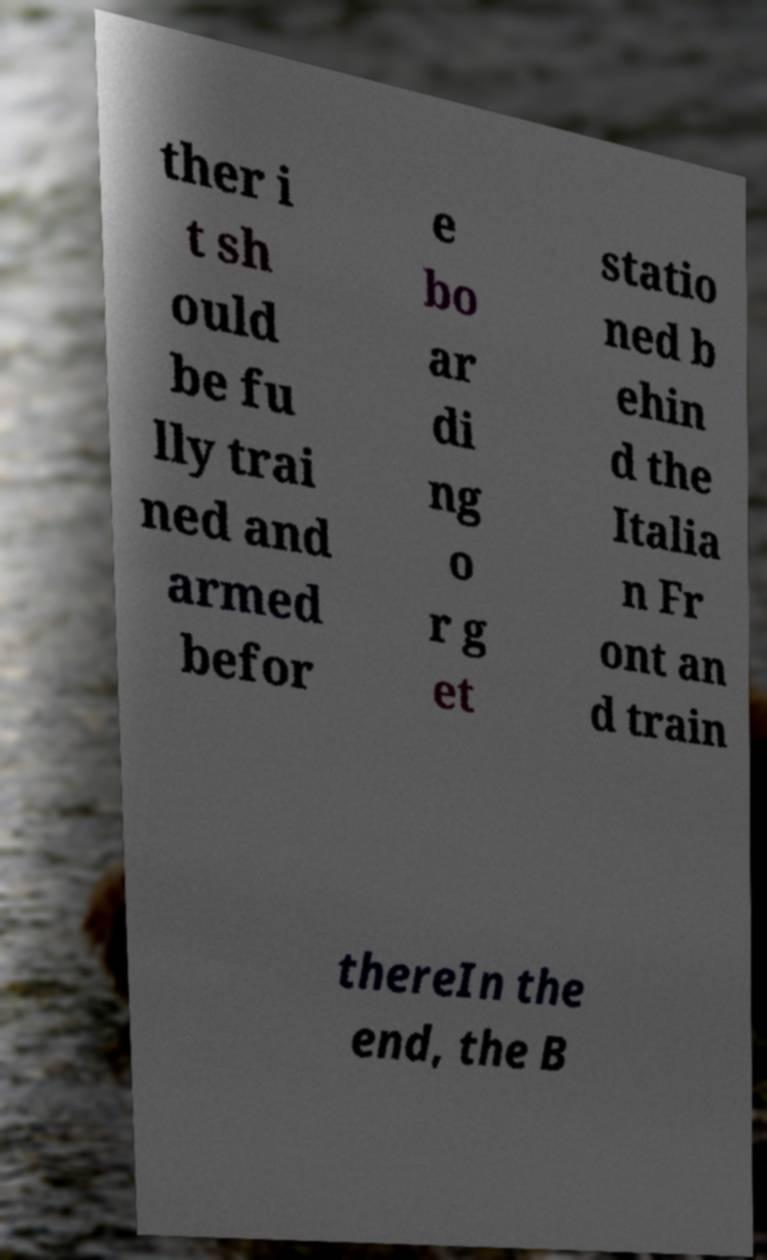What messages or text are displayed in this image? I need them in a readable, typed format. ther i t sh ould be fu lly trai ned and armed befor e bo ar di ng o r g et statio ned b ehin d the Italia n Fr ont an d train thereIn the end, the B 